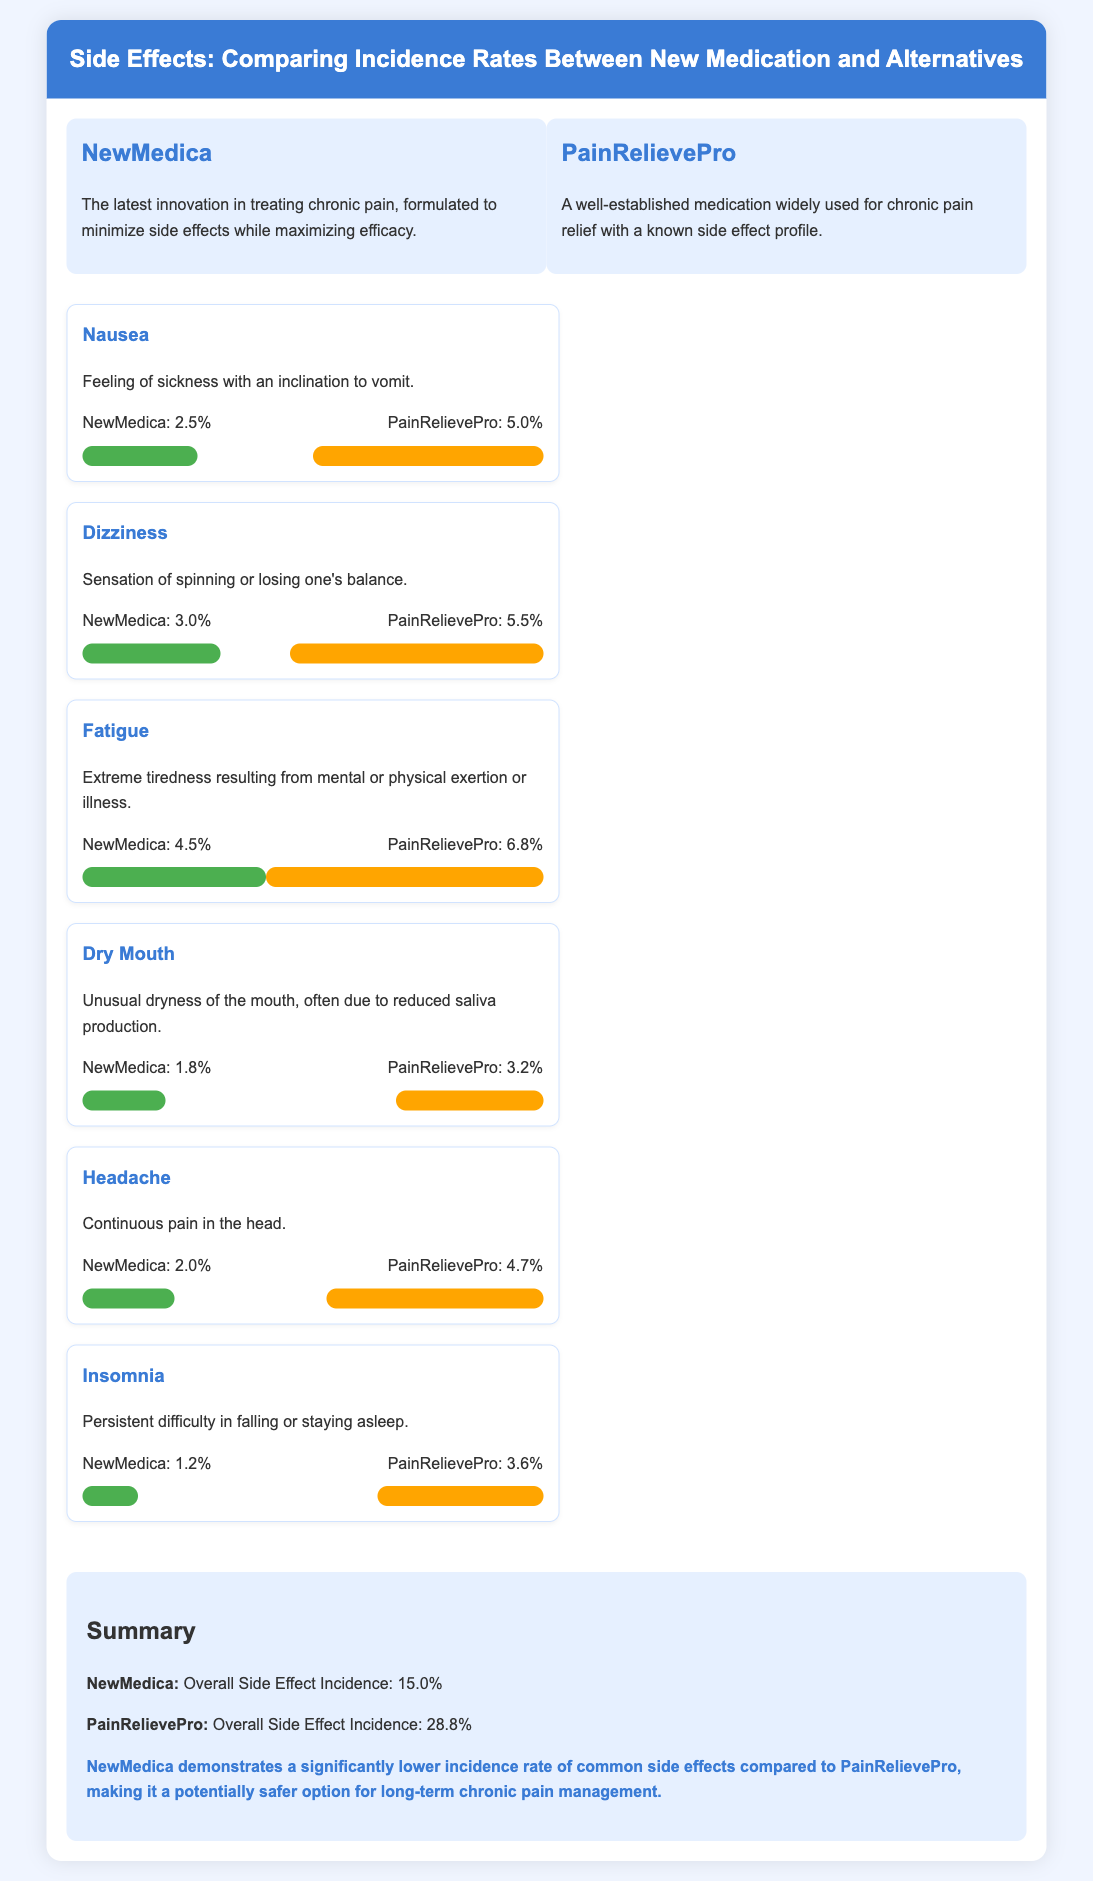What is the side effect incidence rate for NewMedica? NewMedica's overall side effect incidence rate is presented in the summary section of the document.
Answer: 15.0% What side effect has the highest incidence rate for PainRelievePro? The side effect with the highest incidence rate is identified by comparing all the incidence rates listed for PainRelievePro.
Answer: Fatigue What is the incidence rate of dizziness for NewMedica? The specific incidence rate for dizziness under NewMedica is listed in the side effects section.
Answer: 3.0% What is the comparison percentage for Dry Mouth? The comparison percentage is calculated by looking at the two bar values displayed for Dry Mouth in the side effects section.
Answer: NewMedica: 18%, PainRelievePro: 32% How does the incidence of nausea compare between the two medications? The comparison shows the percentages of nausea for both medications side by side in the infographic.
Answer: NewMedica: 2.5%, PainRelievePro: 5.0% Which medication has a lower incidence of headaches? The lower incidence rate can be determined by comparing the headache rates mentioned for both medications.
Answer: NewMedica What percentage of patients experience insomnia with PainRelievePro? The percentage for insomnia under PainRelievePro is specified in the side effects section.
Answer: 3.6% Which medication is described as the latest innovation? The medication characterized as a latest innovation is identified in the medication info section.
Answer: NewMedica What is the key conclusion from the summary section? The conclusion is derived from the overall comparison of side effects incidence rates presented in the infographic.
Answer: NewMedica demonstrates a significantly lower incidence rate of common side effects compared to PainRelievePro 